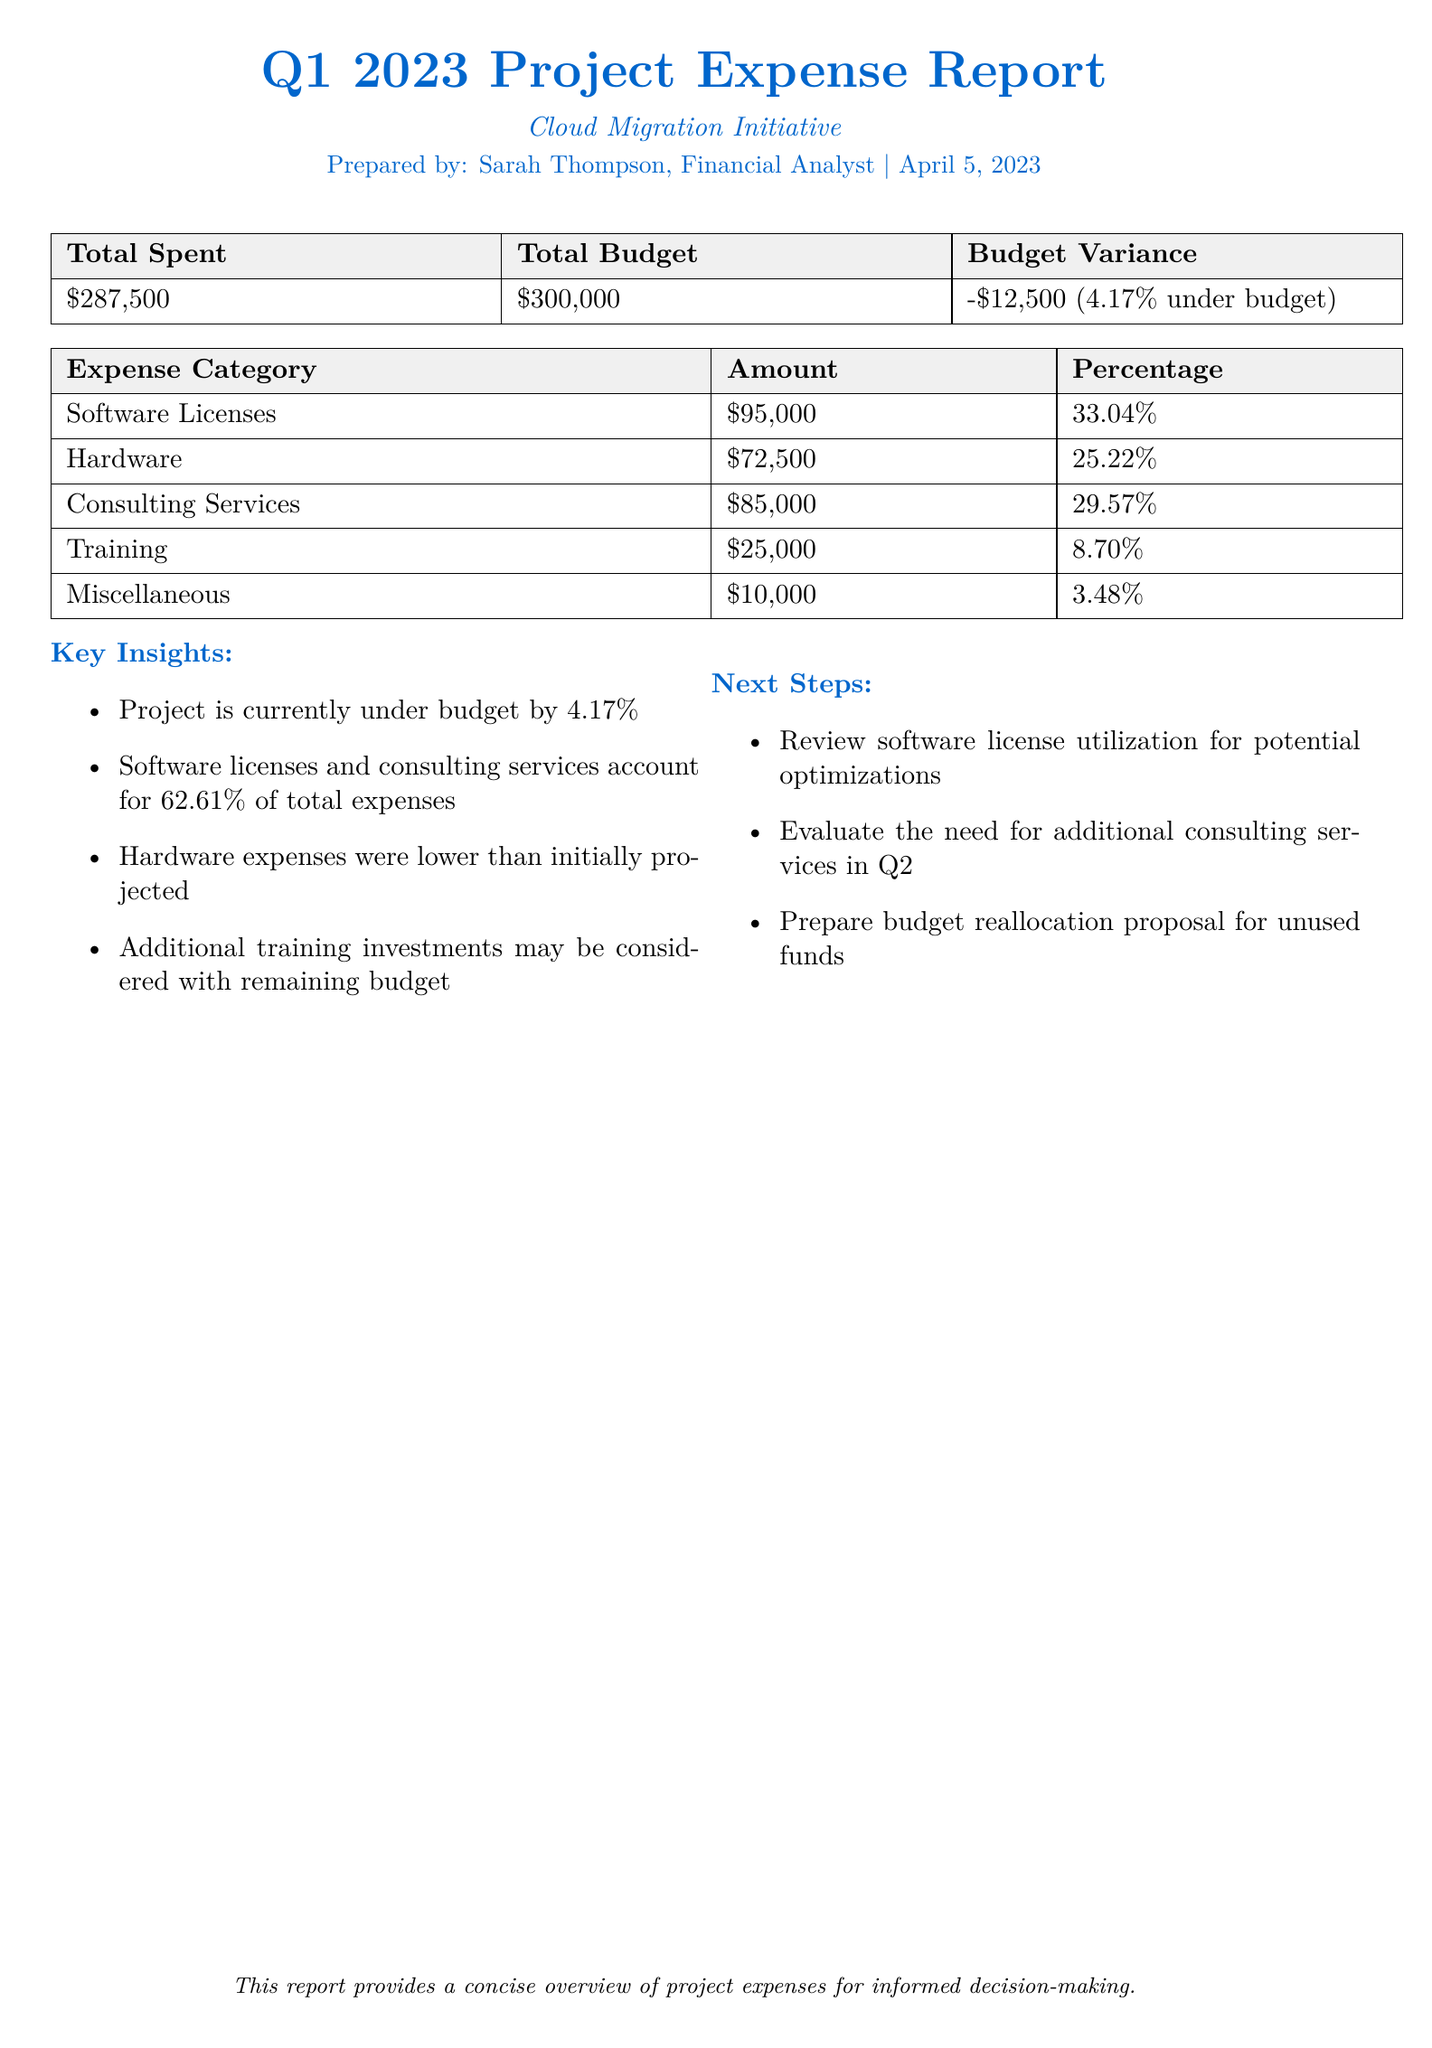What is the total spent? The total spent is stated in the report and is an explicit figure provided in the expense summary, which is $287,500.
Answer: $287,500 What is the total budget? The total budget is listed in the document under the expense summary, showing the allocated amount for the project, which is $300,000.
Answer: $300,000 What is the budget variance? The budget variance is calculated and presented in the expense summary, indicating the difference between the budget and the actual spending, which is -$12,500.
Answer: -$12,500 Which category has the highest expense? The category with the highest expense is indicated in the table of expenses, which shows that Software Licenses amount to $95,000.
Answer: Software Licenses What percentage of total expenses do consulting services account for? The percentage for consulting services is included in the expense breakdown, showing it is 29.57% of the total expenses.
Answer: 29.57% How much was spent on training? The amount spent on training is provided in the expense breakdown and is clearly stated as $25,000.
Answer: $25,000 What is one key insight regarding the project's budget status? One key insight from the document is that the project is currently under budget by 4.17%.
Answer: Under budget by 4.17% What is a suggested next step for budget management? A suggested next step is included in the report, which emphasizes preparing a budget reallocation proposal for unused funds.
Answer: Prepare budget reallocation proposal What percentage of total expenses is attributed to hardware? The expense breakdown indicates that hardware costs account for 25.22% of total expenses.
Answer: 25.22% 